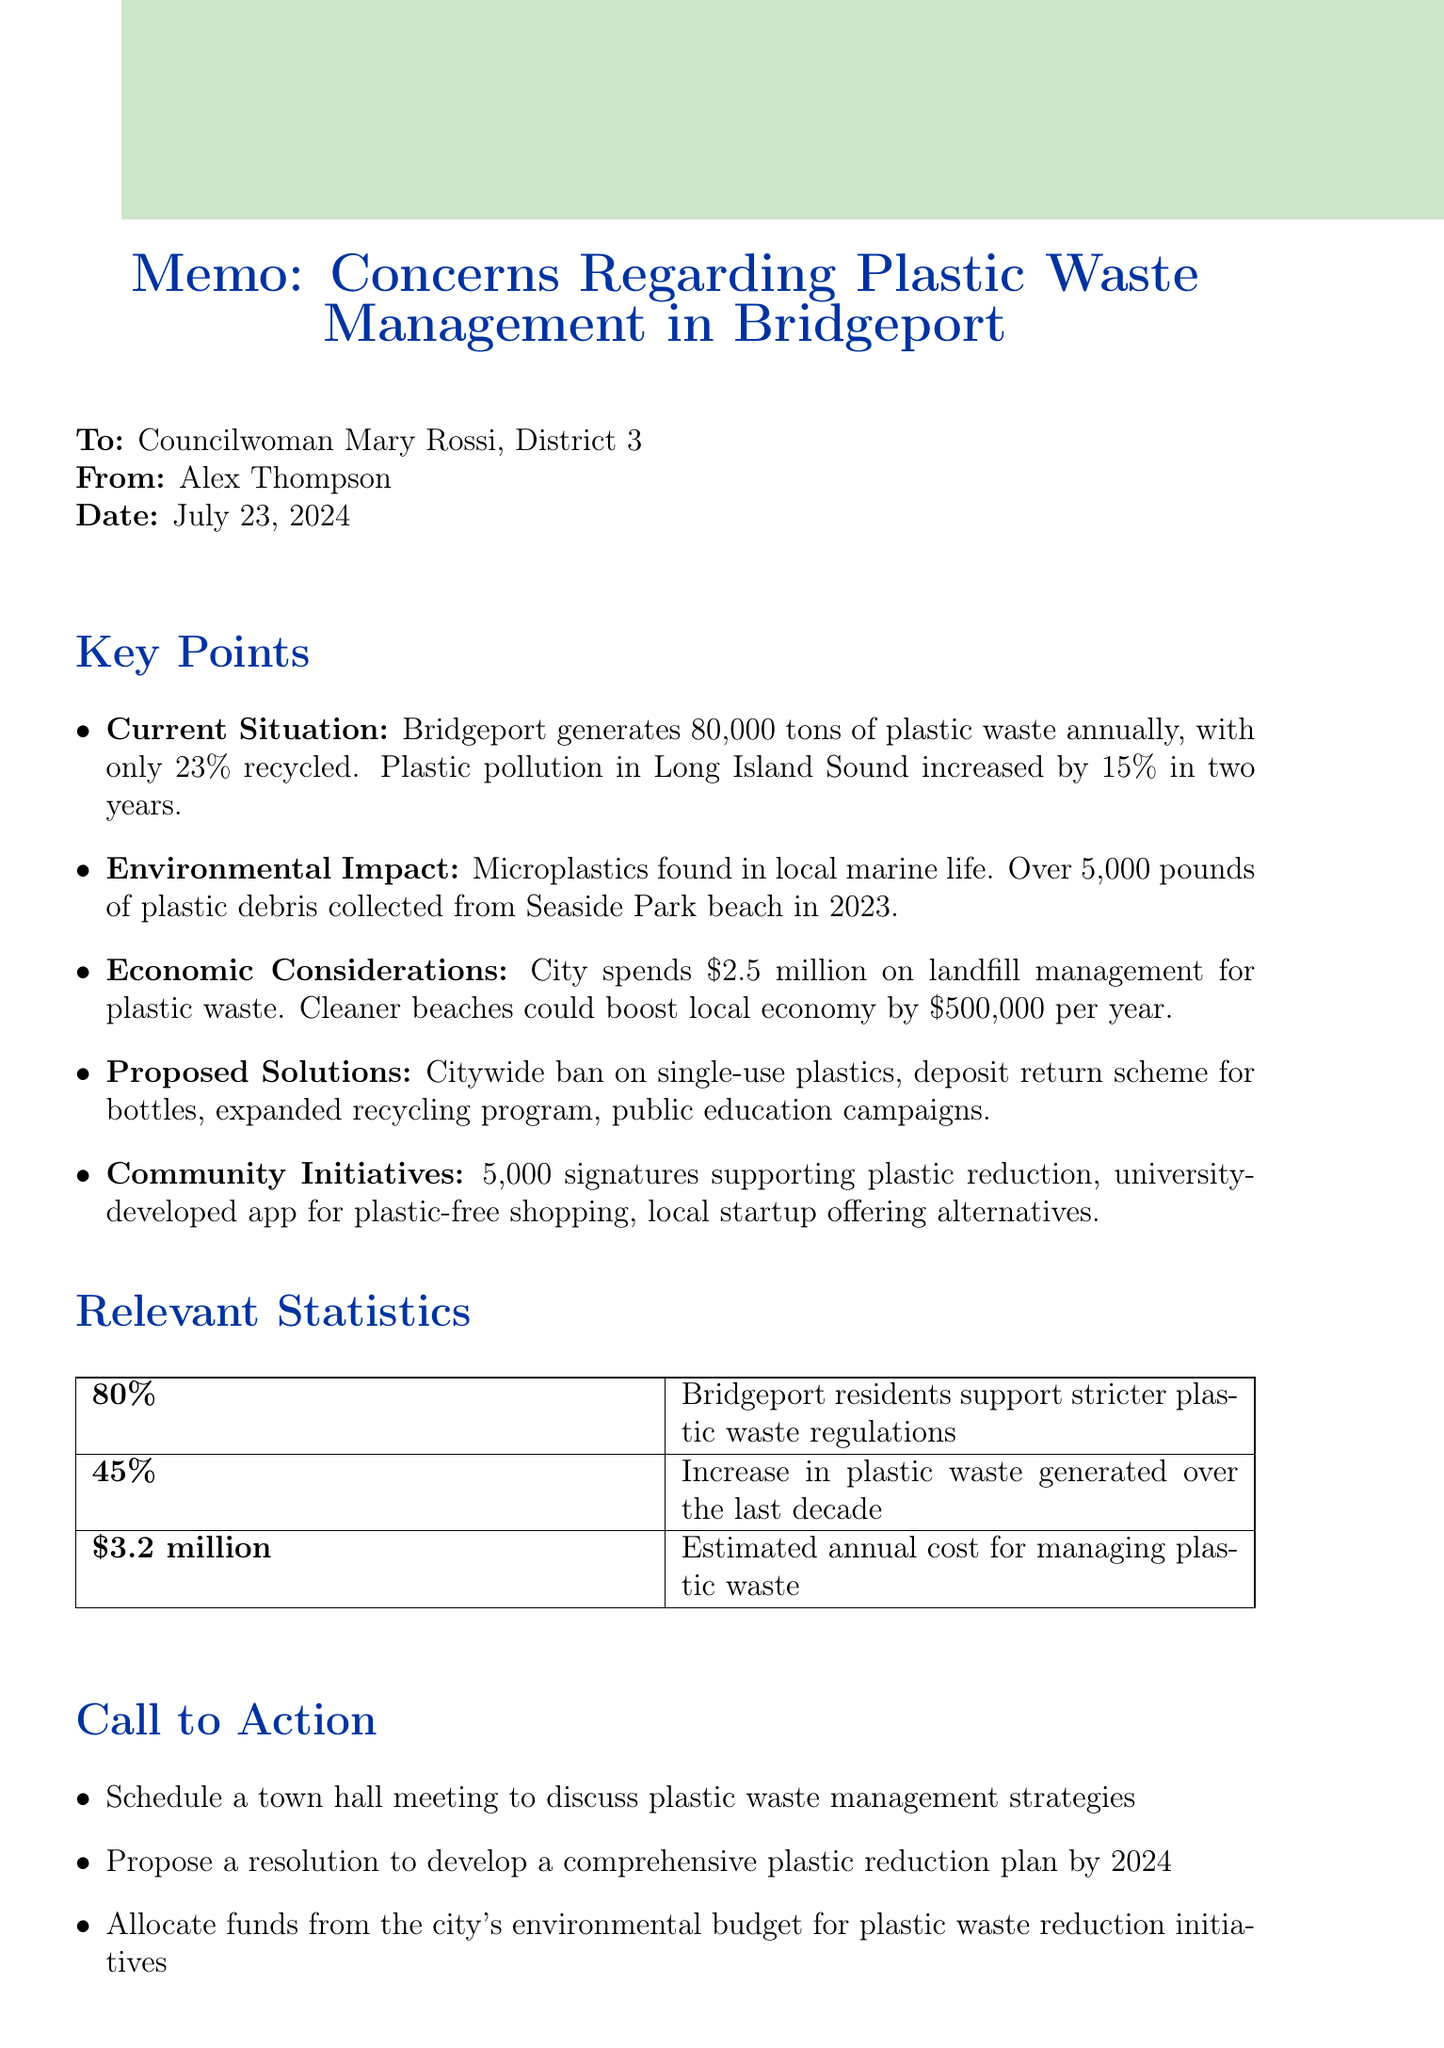What is the title of the memo? The title of the memo outlines the main topic of the document, which is focused on plastic waste management in Bridgeport.
Answer: Concerns Regarding Plastic Waste Management in Bridgeport Who is the memo addressed to? The recipient of the memo is specifically mentioned, indicating who the sender is addressing their concerns to.
Answer: Councilwoman Mary Rossi, District 3 How much plastic waste does Bridgeport generate annually? The memo provides a specific figure regarding the annual generation of plastic waste in the city.
Answer: 80,000 tons What percentage of plastic waste is currently recycled in Bridgeport? The document states a specific recycling rate, revealing the efficiency of the current waste management system.
Answer: 23% What is the proposed plan for plastic bottles mentioned in the memo? This solution suggests a specific action to improve recycling rates and reduce plastic waste.
Answer: Deposit return scheme How many signatures did the Bridgeport Sustainability Coalition's petition gather? This figure highlights community support for reducing plastic waste, showing civic engagement on the issue.
Answer: 5,000 signatures What is the estimated annual cost for managing plastic waste according to the memo? The document provides an estimation of the city's financial burden in managing plastic waste.
Answer: $3.2 million What is one of the community initiatives mentioned in the memo? The memo lists various initiatives aimed at reducing plastic waste, highlighting local efforts.
Answer: University of Bridgeport students developed an app When is the proposed comprehensive plastic reduction plan expected to be developed? This detail shows the timeline for proposed action on plastic waste management.
Answer: By 2024 What is the closing statement's appeal to the recipient? The closing statement expresses the urgency and importance of taking action regarding plastic waste management.
Answer: Prioritize this issue and take decisive action to address plastic waste management in Bridgeport 